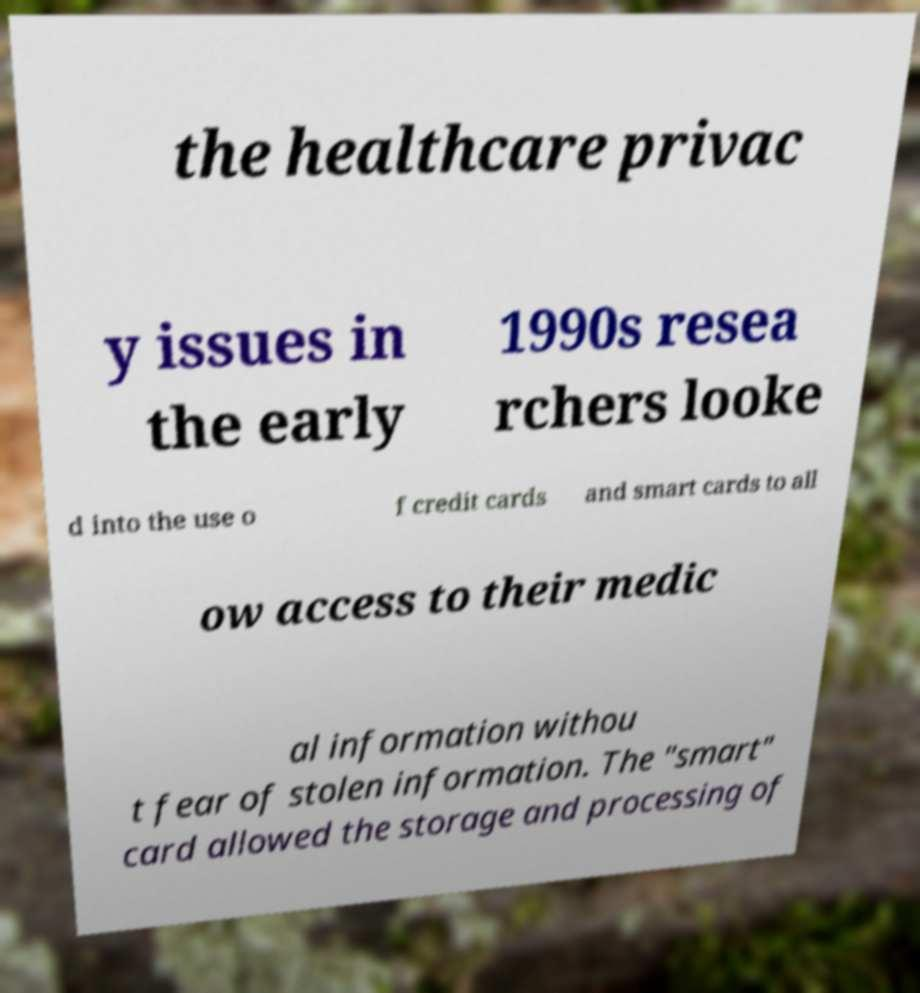Could you extract and type out the text from this image? the healthcare privac y issues in the early 1990s resea rchers looke d into the use o f credit cards and smart cards to all ow access to their medic al information withou t fear of stolen information. The "smart" card allowed the storage and processing of 